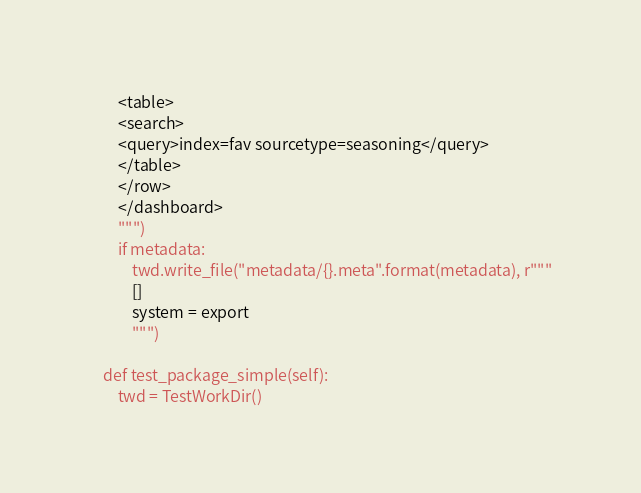Convert code to text. <code><loc_0><loc_0><loc_500><loc_500><_Python_>        <table>
        <search>
        <query>index=fav sourcetype=seasoning</query>
        </table>
        </row>
        </dashboard>
        """)
        if metadata:
            twd.write_file("metadata/{}.meta".format(metadata), r"""
            []
            system = export
            """)

    def test_package_simple(self):
        twd = TestWorkDir()</code> 